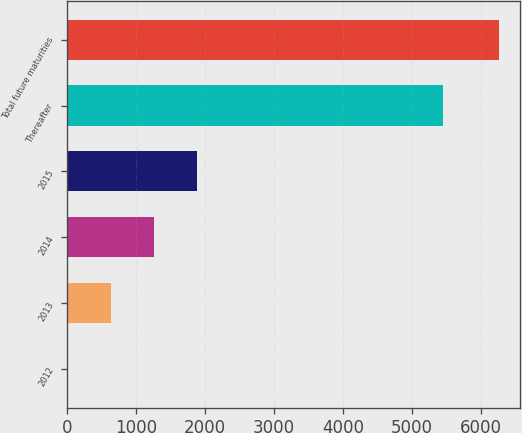Convert chart. <chart><loc_0><loc_0><loc_500><loc_500><bar_chart><fcel>2012<fcel>2013<fcel>2014<fcel>2015<fcel>Thereafter<fcel>Total future maturities<nl><fcel>10<fcel>634.7<fcel>1259.4<fcel>1884.1<fcel>5445<fcel>6257<nl></chart> 